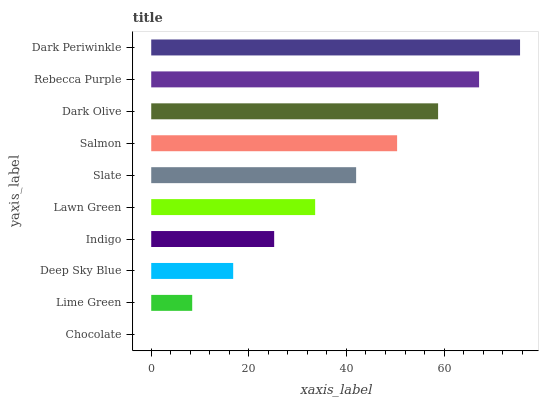Is Chocolate the minimum?
Answer yes or no. Yes. Is Dark Periwinkle the maximum?
Answer yes or no. Yes. Is Lime Green the minimum?
Answer yes or no. No. Is Lime Green the maximum?
Answer yes or no. No. Is Lime Green greater than Chocolate?
Answer yes or no. Yes. Is Chocolate less than Lime Green?
Answer yes or no. Yes. Is Chocolate greater than Lime Green?
Answer yes or no. No. Is Lime Green less than Chocolate?
Answer yes or no. No. Is Slate the high median?
Answer yes or no. Yes. Is Lawn Green the low median?
Answer yes or no. Yes. Is Lime Green the high median?
Answer yes or no. No. Is Slate the low median?
Answer yes or no. No. 